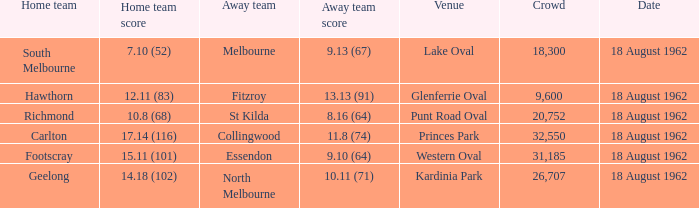What was the home team that scored 10.8 (68)? Richmond. 